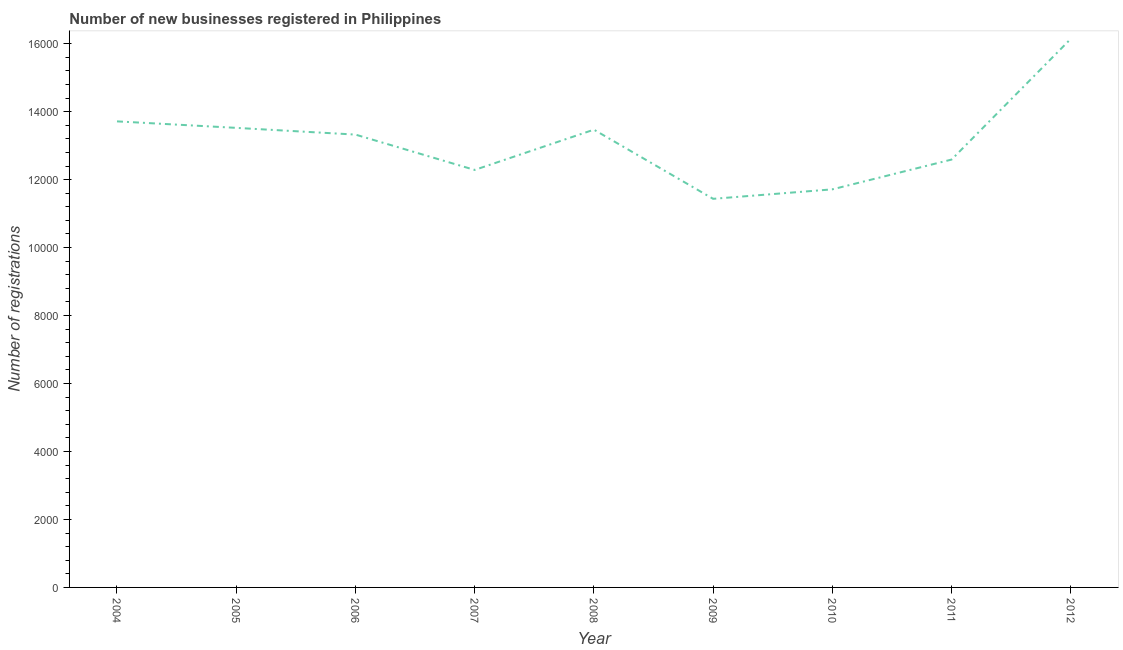What is the number of new business registrations in 2007?
Offer a terse response. 1.23e+04. Across all years, what is the maximum number of new business registrations?
Your answer should be compact. 1.61e+04. Across all years, what is the minimum number of new business registrations?
Provide a succinct answer. 1.14e+04. In which year was the number of new business registrations maximum?
Ensure brevity in your answer.  2012. In which year was the number of new business registrations minimum?
Keep it short and to the point. 2009. What is the sum of the number of new business registrations?
Offer a terse response. 1.18e+05. What is the difference between the number of new business registrations in 2005 and 2007?
Provide a short and direct response. 1238. What is the average number of new business registrations per year?
Offer a terse response. 1.31e+04. What is the median number of new business registrations?
Give a very brief answer. 1.33e+04. What is the ratio of the number of new business registrations in 2009 to that in 2011?
Keep it short and to the point. 0.91. Is the number of new business registrations in 2005 less than that in 2009?
Make the answer very short. No. Is the difference between the number of new business registrations in 2008 and 2011 greater than the difference between any two years?
Provide a succinct answer. No. What is the difference between the highest and the second highest number of new business registrations?
Provide a short and direct response. 2429. What is the difference between the highest and the lowest number of new business registrations?
Give a very brief answer. 4708. Does the number of new business registrations monotonically increase over the years?
Your answer should be compact. No. How many years are there in the graph?
Provide a succinct answer. 9. Does the graph contain any zero values?
Offer a terse response. No. Does the graph contain grids?
Make the answer very short. No. What is the title of the graph?
Your response must be concise. Number of new businesses registered in Philippines. What is the label or title of the X-axis?
Offer a very short reply. Year. What is the label or title of the Y-axis?
Give a very brief answer. Number of registrations. What is the Number of registrations in 2004?
Your response must be concise. 1.37e+04. What is the Number of registrations in 2005?
Make the answer very short. 1.35e+04. What is the Number of registrations of 2006?
Give a very brief answer. 1.33e+04. What is the Number of registrations of 2007?
Keep it short and to the point. 1.23e+04. What is the Number of registrations in 2008?
Your answer should be compact. 1.35e+04. What is the Number of registrations in 2009?
Offer a very short reply. 1.14e+04. What is the Number of registrations in 2010?
Your answer should be compact. 1.17e+04. What is the Number of registrations in 2011?
Provide a succinct answer. 1.26e+04. What is the Number of registrations of 2012?
Ensure brevity in your answer.  1.61e+04. What is the difference between the Number of registrations in 2004 and 2005?
Keep it short and to the point. 191. What is the difference between the Number of registrations in 2004 and 2006?
Your answer should be very brief. 389. What is the difference between the Number of registrations in 2004 and 2007?
Provide a succinct answer. 1429. What is the difference between the Number of registrations in 2004 and 2008?
Your answer should be compact. 244. What is the difference between the Number of registrations in 2004 and 2009?
Your answer should be very brief. 2279. What is the difference between the Number of registrations in 2004 and 2010?
Your response must be concise. 2000. What is the difference between the Number of registrations in 2004 and 2011?
Provide a short and direct response. 1124. What is the difference between the Number of registrations in 2004 and 2012?
Offer a very short reply. -2429. What is the difference between the Number of registrations in 2005 and 2006?
Provide a succinct answer. 198. What is the difference between the Number of registrations in 2005 and 2007?
Your answer should be very brief. 1238. What is the difference between the Number of registrations in 2005 and 2008?
Provide a succinct answer. 53. What is the difference between the Number of registrations in 2005 and 2009?
Provide a succinct answer. 2088. What is the difference between the Number of registrations in 2005 and 2010?
Ensure brevity in your answer.  1809. What is the difference between the Number of registrations in 2005 and 2011?
Keep it short and to the point. 933. What is the difference between the Number of registrations in 2005 and 2012?
Your answer should be very brief. -2620. What is the difference between the Number of registrations in 2006 and 2007?
Keep it short and to the point. 1040. What is the difference between the Number of registrations in 2006 and 2008?
Your response must be concise. -145. What is the difference between the Number of registrations in 2006 and 2009?
Your response must be concise. 1890. What is the difference between the Number of registrations in 2006 and 2010?
Give a very brief answer. 1611. What is the difference between the Number of registrations in 2006 and 2011?
Give a very brief answer. 735. What is the difference between the Number of registrations in 2006 and 2012?
Your response must be concise. -2818. What is the difference between the Number of registrations in 2007 and 2008?
Provide a succinct answer. -1185. What is the difference between the Number of registrations in 2007 and 2009?
Make the answer very short. 850. What is the difference between the Number of registrations in 2007 and 2010?
Keep it short and to the point. 571. What is the difference between the Number of registrations in 2007 and 2011?
Provide a short and direct response. -305. What is the difference between the Number of registrations in 2007 and 2012?
Your response must be concise. -3858. What is the difference between the Number of registrations in 2008 and 2009?
Provide a short and direct response. 2035. What is the difference between the Number of registrations in 2008 and 2010?
Ensure brevity in your answer.  1756. What is the difference between the Number of registrations in 2008 and 2011?
Keep it short and to the point. 880. What is the difference between the Number of registrations in 2008 and 2012?
Provide a short and direct response. -2673. What is the difference between the Number of registrations in 2009 and 2010?
Your response must be concise. -279. What is the difference between the Number of registrations in 2009 and 2011?
Your answer should be very brief. -1155. What is the difference between the Number of registrations in 2009 and 2012?
Keep it short and to the point. -4708. What is the difference between the Number of registrations in 2010 and 2011?
Provide a succinct answer. -876. What is the difference between the Number of registrations in 2010 and 2012?
Your response must be concise. -4429. What is the difference between the Number of registrations in 2011 and 2012?
Ensure brevity in your answer.  -3553. What is the ratio of the Number of registrations in 2004 to that in 2006?
Give a very brief answer. 1.03. What is the ratio of the Number of registrations in 2004 to that in 2007?
Give a very brief answer. 1.12. What is the ratio of the Number of registrations in 2004 to that in 2009?
Make the answer very short. 1.2. What is the ratio of the Number of registrations in 2004 to that in 2010?
Your answer should be very brief. 1.17. What is the ratio of the Number of registrations in 2004 to that in 2011?
Offer a terse response. 1.09. What is the ratio of the Number of registrations in 2005 to that in 2007?
Keep it short and to the point. 1.1. What is the ratio of the Number of registrations in 2005 to that in 2008?
Your answer should be very brief. 1. What is the ratio of the Number of registrations in 2005 to that in 2009?
Give a very brief answer. 1.18. What is the ratio of the Number of registrations in 2005 to that in 2010?
Ensure brevity in your answer.  1.15. What is the ratio of the Number of registrations in 2005 to that in 2011?
Your response must be concise. 1.07. What is the ratio of the Number of registrations in 2005 to that in 2012?
Provide a short and direct response. 0.84. What is the ratio of the Number of registrations in 2006 to that in 2007?
Ensure brevity in your answer.  1.08. What is the ratio of the Number of registrations in 2006 to that in 2009?
Keep it short and to the point. 1.17. What is the ratio of the Number of registrations in 2006 to that in 2010?
Keep it short and to the point. 1.14. What is the ratio of the Number of registrations in 2006 to that in 2011?
Ensure brevity in your answer.  1.06. What is the ratio of the Number of registrations in 2006 to that in 2012?
Your answer should be compact. 0.82. What is the ratio of the Number of registrations in 2007 to that in 2008?
Give a very brief answer. 0.91. What is the ratio of the Number of registrations in 2007 to that in 2009?
Make the answer very short. 1.07. What is the ratio of the Number of registrations in 2007 to that in 2010?
Ensure brevity in your answer.  1.05. What is the ratio of the Number of registrations in 2007 to that in 2012?
Give a very brief answer. 0.76. What is the ratio of the Number of registrations in 2008 to that in 2009?
Your response must be concise. 1.18. What is the ratio of the Number of registrations in 2008 to that in 2010?
Ensure brevity in your answer.  1.15. What is the ratio of the Number of registrations in 2008 to that in 2011?
Offer a terse response. 1.07. What is the ratio of the Number of registrations in 2008 to that in 2012?
Provide a succinct answer. 0.83. What is the ratio of the Number of registrations in 2009 to that in 2011?
Make the answer very short. 0.91. What is the ratio of the Number of registrations in 2009 to that in 2012?
Ensure brevity in your answer.  0.71. What is the ratio of the Number of registrations in 2010 to that in 2011?
Offer a very short reply. 0.93. What is the ratio of the Number of registrations in 2010 to that in 2012?
Provide a short and direct response. 0.73. What is the ratio of the Number of registrations in 2011 to that in 2012?
Give a very brief answer. 0.78. 